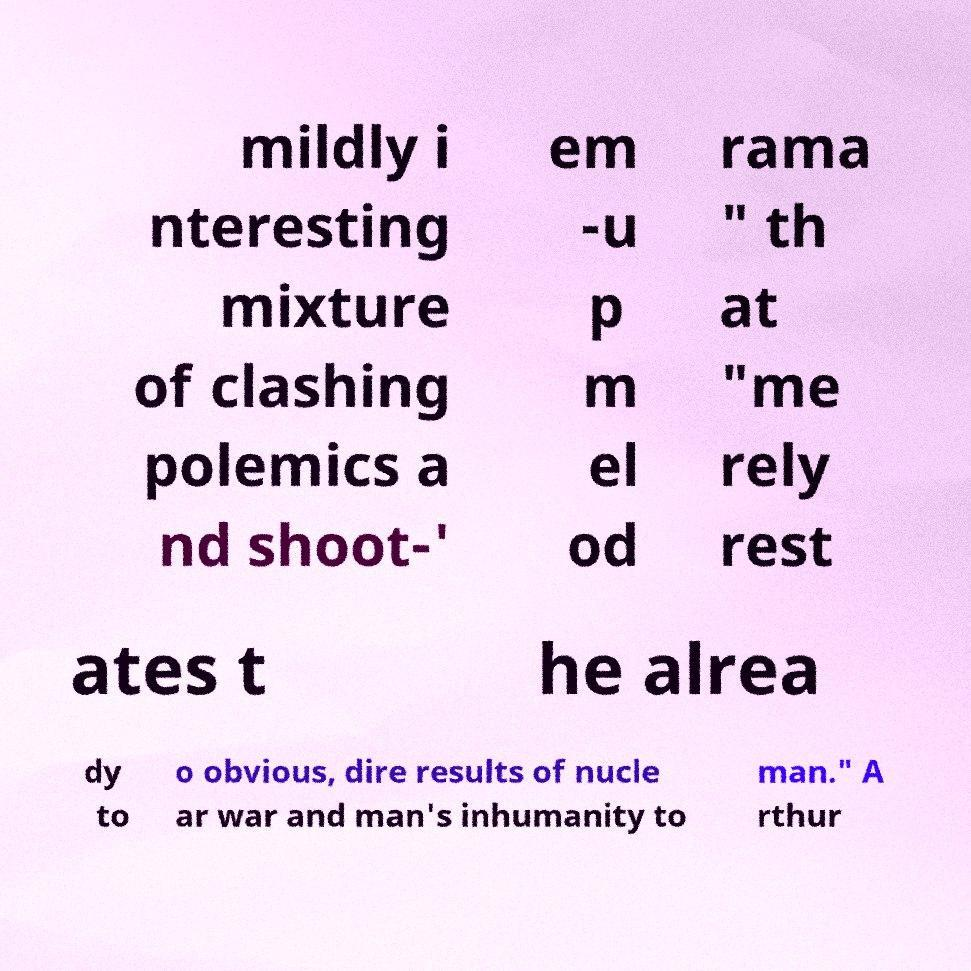There's text embedded in this image that I need extracted. Can you transcribe it verbatim? mildly i nteresting mixture of clashing polemics a nd shoot-' em -u p m el od rama " th at "me rely rest ates t he alrea dy to o obvious, dire results of nucle ar war and man's inhumanity to man." A rthur 